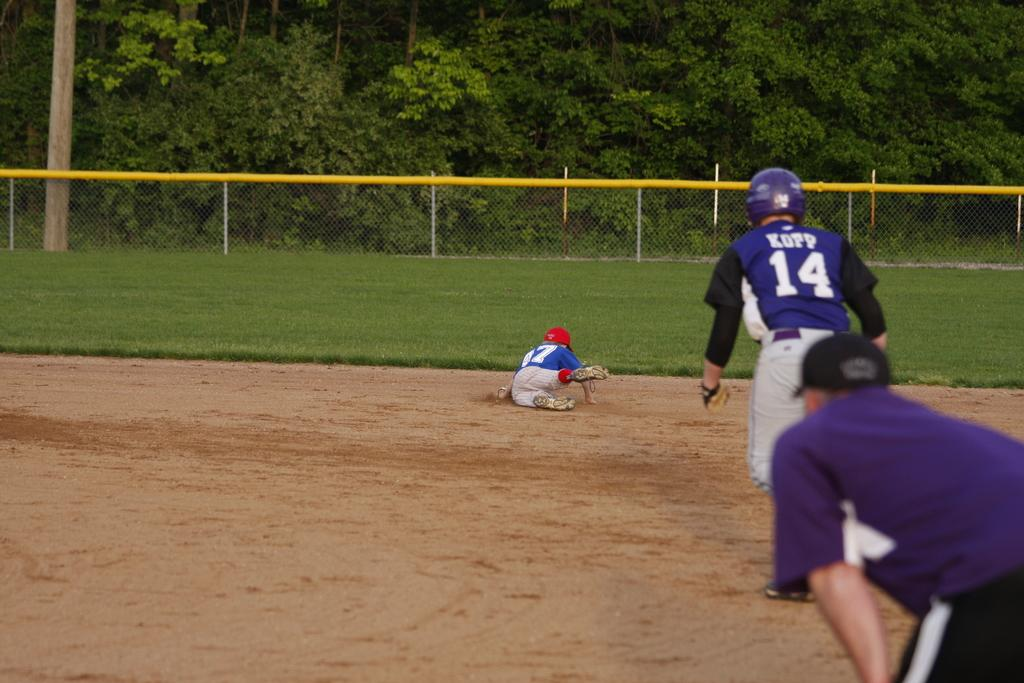<image>
Relay a brief, clear account of the picture shown. Baseball hitter no. 14 looks on as the defender dives for the ball. 